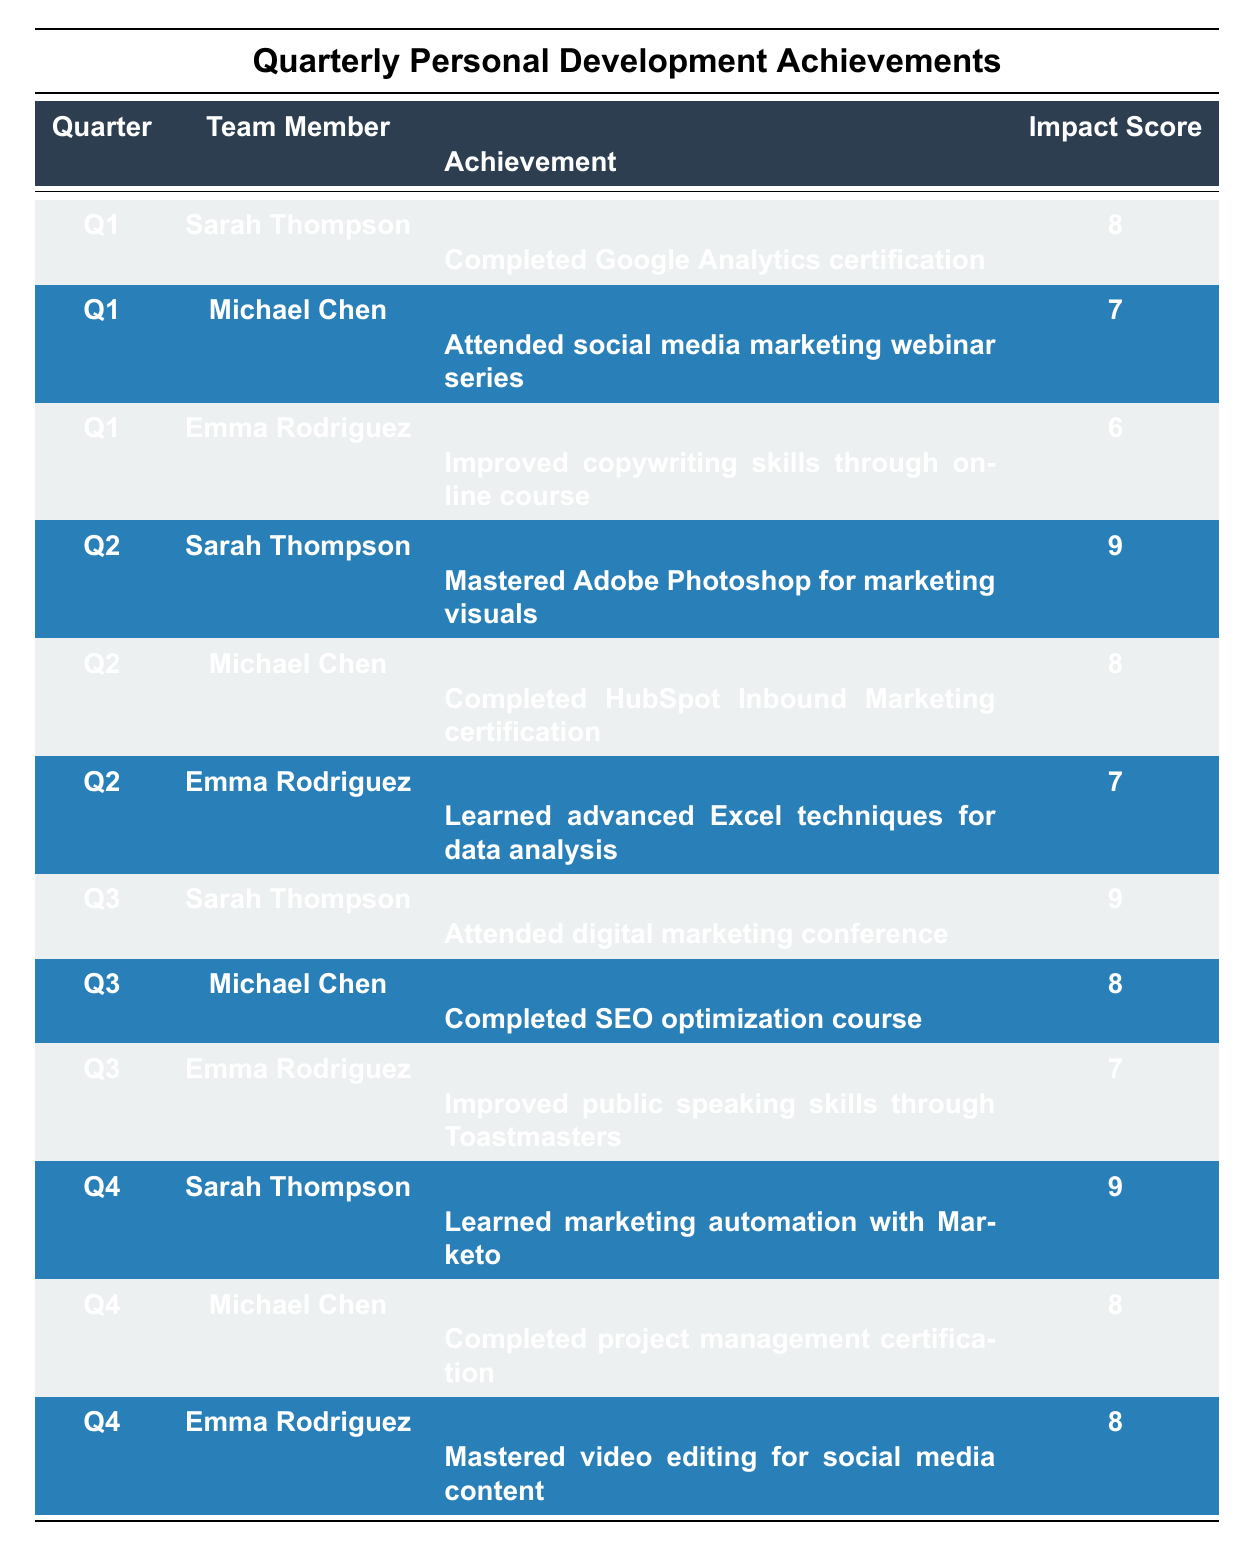What achievement did Sarah Thompson accomplish in Q2? In the table, under the Q2 section, we can see that Sarah Thompson's achievement is listed as "Mastered Adobe Photoshop for marketing visuals."
Answer: Mastered Adobe Photoshop for marketing visuals Which team member had the highest impact score in Q1? Looking at the Q1 section, the highest impact score is 8, which belongs to Sarah Thompson for her achievement "Completed Google Analytics certification."
Answer: Sarah Thompson What is the average impact score for all achievements listed in Q3? In Q3, the impact scores are 9 (Sarah Thompson), 8 (Michael Chen), and 7 (Emma Rodriguez). To find the average, we sum the scores (9 + 8 + 7) = 24 and then divide by the number of achievements, which is 3. 24/3 = 8.
Answer: 8 Did Emma Rodriguez improve her public speaking skills in Q2? In the table, Emma Rodriguez’s achievements in Q2 include “Learned advanced Excel techniques for data analysis.” There is no mention of public speaking improvements in Q2.
Answer: No What is the total impact score for Sarah Thompson across all quarters? The impact scores for Sarah Thompson are 8 (Q1), 9 (Q2), 9 (Q3), and 9 (Q4). Adding them gives us a total of 8 + 9 + 9 + 9 = 35.
Answer: 35 Which achievement had an impact score lower than 7 in Q1? In Q1, the achievements were "Completed Google Analytics certification" (8), "Attended social media marketing webinar series" (7), and "Improved copywriting skills through online course" (6). Only the last one has an impact score lower than 7.
Answer: Improved copywriting skills through online course Which team member consistently has the highest impact score each quarter? Reviewing the quarterly achievements, Sarah Thompson has the highest impact scores of 9 in Q2, Q3, and Q4. In Q1, she scored 8, which is still high, but comparison shows she is one of the top performers without consistently being the absolute highest in every quarter.
Answer: No single member consistently has the highest score What was Michael Chen's achievement in Q4? In looking at the Q4 achievements, Michael Chen's is "Completed project management certification," which is clearly stated in that section of the table.
Answer: Completed project management certification Which skill did Emma Rodriguez master in Q4? In Q4, Emma Rodriguez's achievement is listed as "Mastered video editing for social media content," thus indicating the specific skill she mastered during that quarter.
Answer: Mastered video editing for social media content What is the difference in impact scores between Michael Chen's achievements in Q2 and Q3? In Q2, Michael Chen has an impact score of 8 for "Completed HubSpot Inbound Marketing certification," while in Q3, he scored 8 for "Completed SEO optimization course." The difference is 8 - 8 = 0.
Answer: 0 